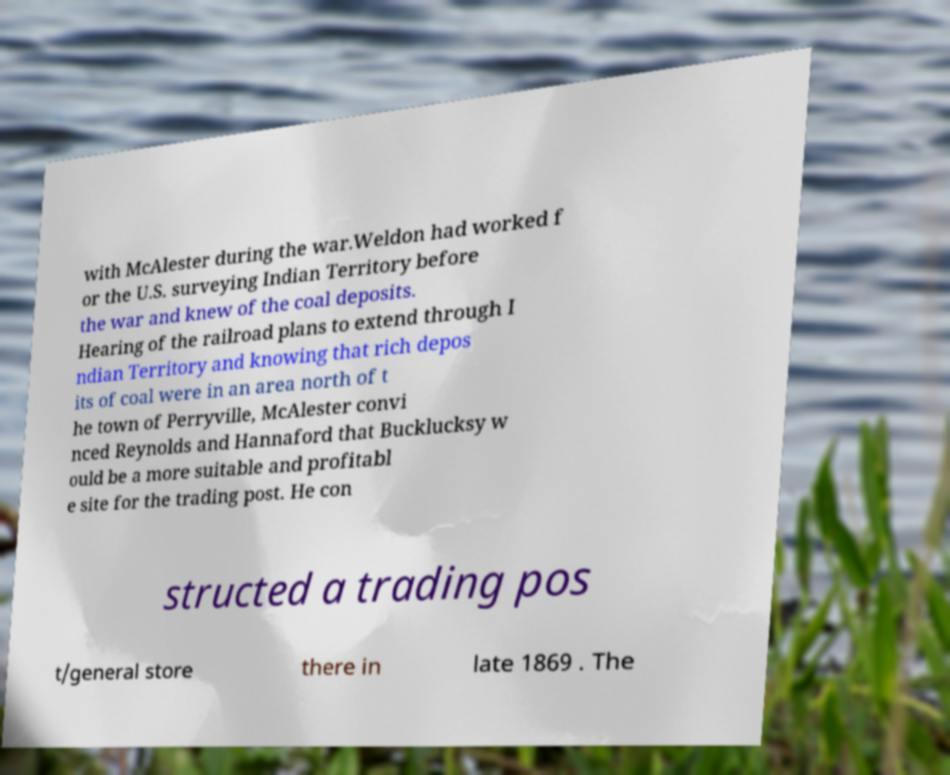Please identify and transcribe the text found in this image. with McAlester during the war.Weldon had worked f or the U.S. surveying Indian Territory before the war and knew of the coal deposits. Hearing of the railroad plans to extend through I ndian Territory and knowing that rich depos its of coal were in an area north of t he town of Perryville, McAlester convi nced Reynolds and Hannaford that Bucklucksy w ould be a more suitable and profitabl e site for the trading post. He con structed a trading pos t/general store there in late 1869 . The 